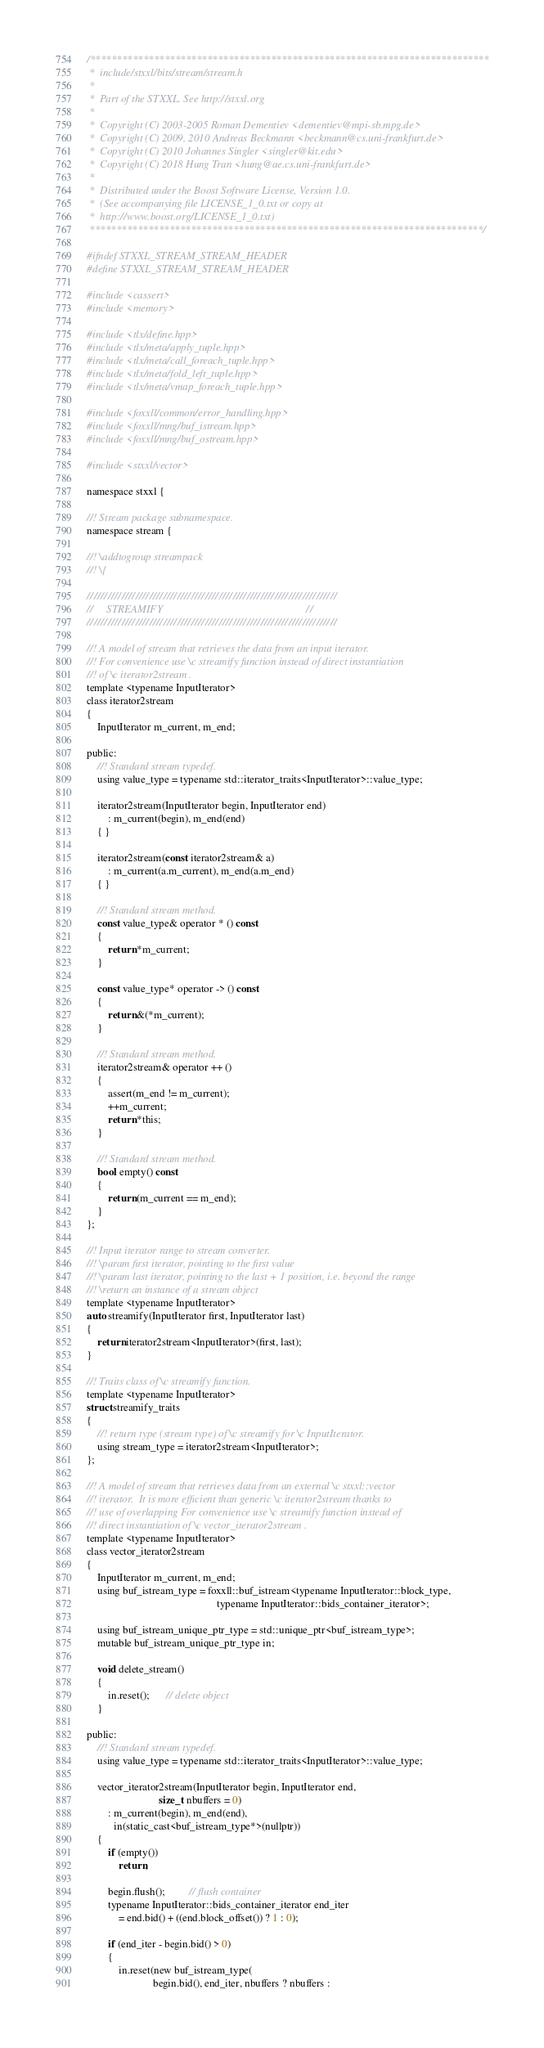<code> <loc_0><loc_0><loc_500><loc_500><_C_>/***************************************************************************
 *  include/stxxl/bits/stream/stream.h
 *
 *  Part of the STXXL. See http://stxxl.org
 *
 *  Copyright (C) 2003-2005 Roman Dementiev <dementiev@mpi-sb.mpg.de>
 *  Copyright (C) 2009, 2010 Andreas Beckmann <beckmann@cs.uni-frankfurt.de>
 *  Copyright (C) 2010 Johannes Singler <singler@kit.edu>
 *  Copyright (C) 2018 Hung Tran <hung@ae.cs.uni-frankfurt.de>
 *
 *  Distributed under the Boost Software License, Version 1.0.
 *  (See accompanying file LICENSE_1_0.txt or copy at
 *  http://www.boost.org/LICENSE_1_0.txt)
 **************************************************************************/

#ifndef STXXL_STREAM_STREAM_HEADER
#define STXXL_STREAM_STREAM_HEADER

#include <cassert>
#include <memory>

#include <tlx/define.hpp>
#include <tlx/meta/apply_tuple.hpp>
#include <tlx/meta/call_foreach_tuple.hpp>
#include <tlx/meta/fold_left_tuple.hpp>
#include <tlx/meta/vmap_foreach_tuple.hpp>

#include <foxxll/common/error_handling.hpp>
#include <foxxll/mng/buf_istream.hpp>
#include <foxxll/mng/buf_ostream.hpp>

#include <stxxl/vector>

namespace stxxl {

//! Stream package subnamespace.
namespace stream {

//! \addtogroup streampack
//! \{

////////////////////////////////////////////////////////////////////////
//     STREAMIFY                                                      //
////////////////////////////////////////////////////////////////////////

//! A model of stream that retrieves the data from an input iterator.
//! For convenience use \c streamify function instead of direct instantiation
//! of \c iterator2stream .
template <typename InputIterator>
class iterator2stream
{
    InputIterator m_current, m_end;

public:
    //! Standard stream typedef.
    using value_type = typename std::iterator_traits<InputIterator>::value_type;

    iterator2stream(InputIterator begin, InputIterator end)
        : m_current(begin), m_end(end)
    { }

    iterator2stream(const iterator2stream& a)
        : m_current(a.m_current), m_end(a.m_end)
    { }

    //! Standard stream method.
    const value_type& operator * () const
    {
        return *m_current;
    }

    const value_type* operator -> () const
    {
        return &(*m_current);
    }

    //! Standard stream method.
    iterator2stream& operator ++ ()
    {
        assert(m_end != m_current);
        ++m_current;
        return *this;
    }

    //! Standard stream method.
    bool empty() const
    {
        return (m_current == m_end);
    }
};

//! Input iterator range to stream converter.
//! \param first iterator, pointing to the first value
//! \param last iterator, pointing to the last + 1 position, i.e. beyond the range
//! \return an instance of a stream object
template <typename InputIterator>
auto streamify(InputIterator first, InputIterator last)
{
    return iterator2stream<InputIterator>(first, last);
}

//! Traits class of \c streamify function.
template <typename InputIterator>
struct streamify_traits
{
    //! return type (stream type) of \c streamify for \c InputIterator.
    using stream_type = iterator2stream<InputIterator>;
};

//! A model of stream that retrieves data from an external \c stxxl::vector
//! iterator.  It is more efficient than generic \c iterator2stream thanks to
//! use of overlapping For convenience use \c streamify function instead of
//! direct instantiation of \c vector_iterator2stream .
template <typename InputIterator>
class vector_iterator2stream
{
    InputIterator m_current, m_end;
    using buf_istream_type = foxxll::buf_istream<typename InputIterator::block_type,
                                                 typename InputIterator::bids_container_iterator>;

    using buf_istream_unique_ptr_type = std::unique_ptr<buf_istream_type>;
    mutable buf_istream_unique_ptr_type in;

    void delete_stream()
    {
        in.reset();      // delete object
    }

public:
    //! Standard stream typedef.
    using value_type = typename std::iterator_traits<InputIterator>::value_type;

    vector_iterator2stream(InputIterator begin, InputIterator end,
                           size_t nbuffers = 0)
        : m_current(begin), m_end(end),
          in(static_cast<buf_istream_type*>(nullptr))
    {
        if (empty())
            return;

        begin.flush();         // flush container
        typename InputIterator::bids_container_iterator end_iter
            = end.bid() + ((end.block_offset()) ? 1 : 0);

        if (end_iter - begin.bid() > 0)
        {
            in.reset(new buf_istream_type(
                         begin.bid(), end_iter, nbuffers ? nbuffers :</code> 